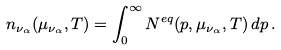<formula> <loc_0><loc_0><loc_500><loc_500>n _ { \nu _ { \alpha } } ( \mu _ { \nu _ { \alpha } } , T ) = \int _ { 0 } ^ { \infty } N ^ { e q } ( p , \mu _ { \nu _ { \alpha } } , T ) \, d p \, .</formula> 